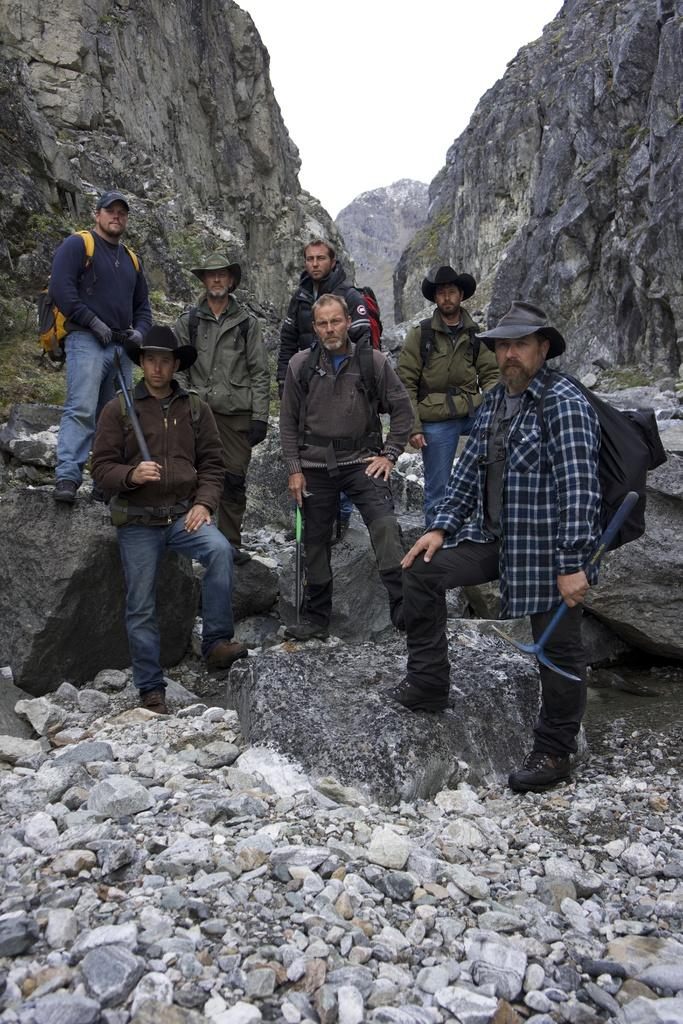Who or what is present in the image? There are people in the image. What type of natural features can be seen in the image? There are rocks, stones, and hills in the image. What is visible in the background of the image? The sky is visible in the background of the image. What type of pleasure can be seen being experienced by the people in the image? There is no indication of pleasure being experienced by the people in the image. The image only shows people, rocks, stones, hills, and the sky. 